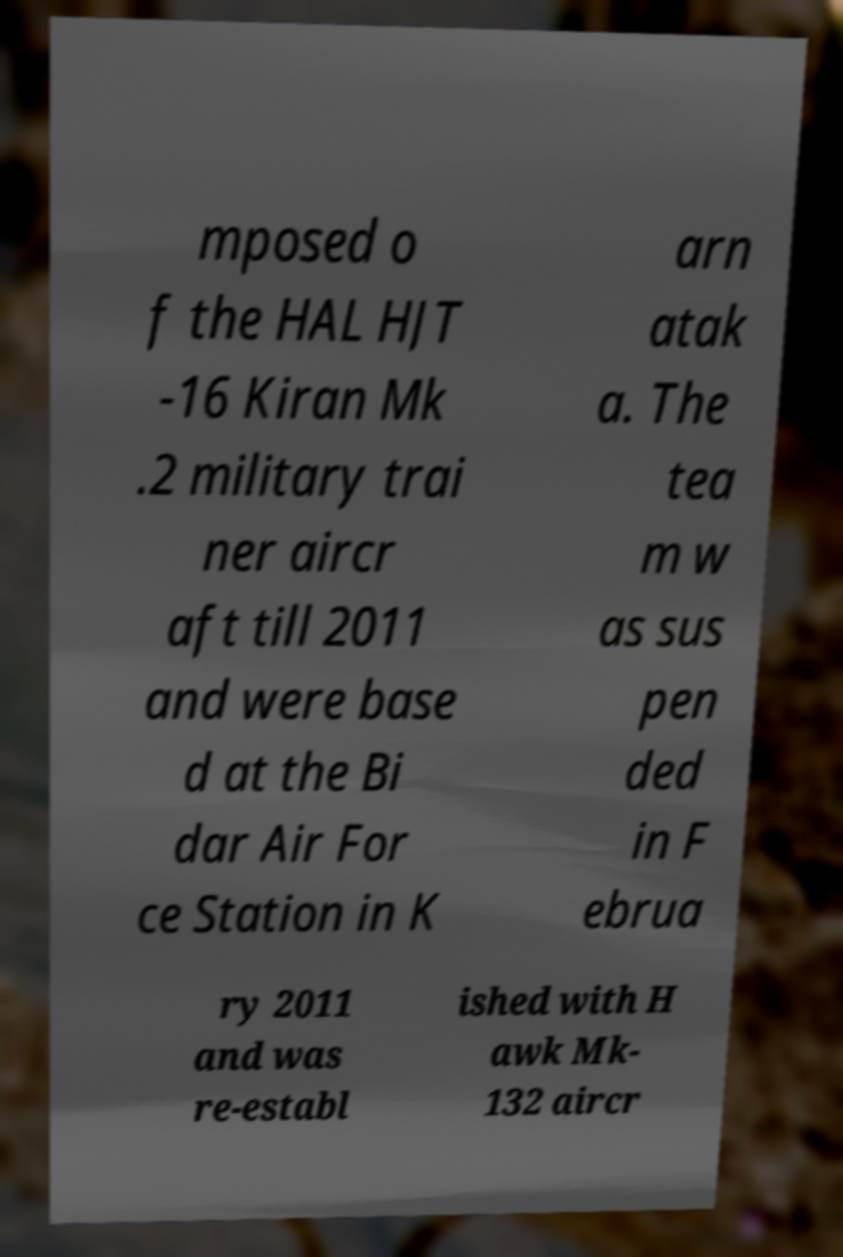Please read and relay the text visible in this image. What does it say? mposed o f the HAL HJT -16 Kiran Mk .2 military trai ner aircr aft till 2011 and were base d at the Bi dar Air For ce Station in K arn atak a. The tea m w as sus pen ded in F ebrua ry 2011 and was re-establ ished with H awk Mk- 132 aircr 